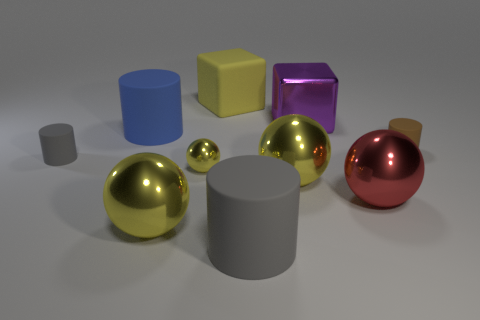Is the tiny yellow object that is on the left side of the big gray rubber thing made of the same material as the gray thing to the left of the large yellow rubber cube?
Ensure brevity in your answer.  No. What is the material of the blue thing that is the same shape as the brown matte thing?
Your response must be concise. Rubber. Is there any other thing that is the same size as the red thing?
Offer a very short reply. Yes. There is a large purple object behind the blue cylinder; is its shape the same as the small rubber thing left of the big yellow rubber cube?
Your response must be concise. No. Are there fewer cylinders in front of the large gray matte object than metallic balls behind the brown matte cylinder?
Your response must be concise. No. How many other objects are the same shape as the big red object?
Provide a short and direct response. 3. The blue object that is the same material as the large gray cylinder is what shape?
Your response must be concise. Cylinder. There is a cylinder that is left of the red metallic object and behind the tiny gray matte object; what is its color?
Provide a short and direct response. Blue. Is the big cube that is right of the yellow cube made of the same material as the blue cylinder?
Offer a very short reply. No. Is the number of big blue matte objects that are on the right side of the purple metal object less than the number of tiny red objects?
Your response must be concise. No. 